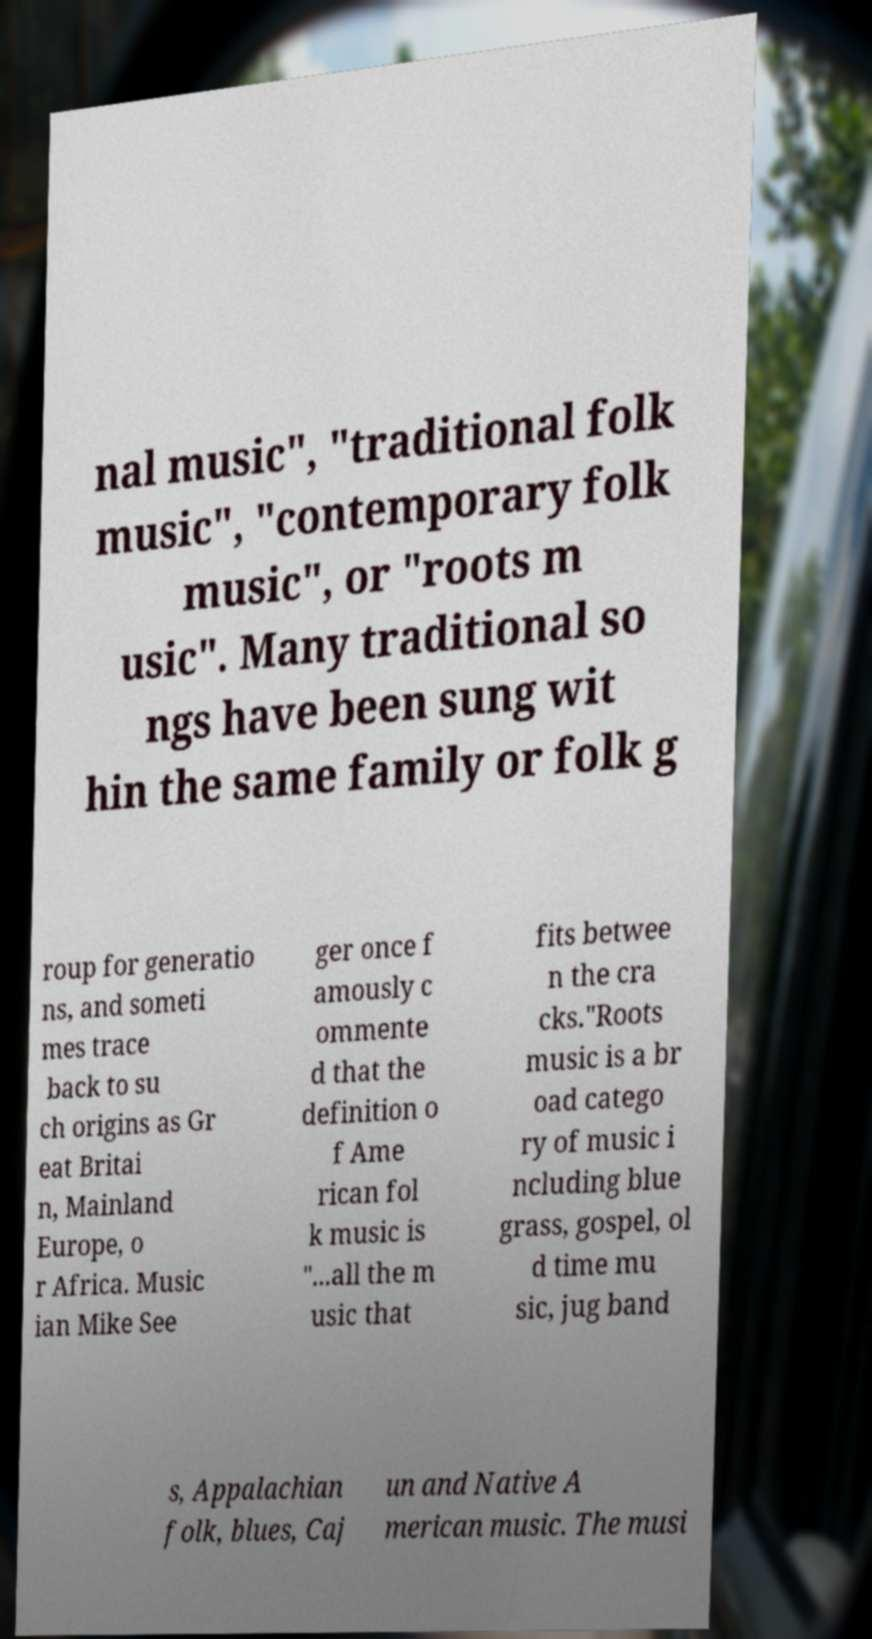Can you read and provide the text displayed in the image?This photo seems to have some interesting text. Can you extract and type it out for me? nal music", "traditional folk music", "contemporary folk music", or "roots m usic". Many traditional so ngs have been sung wit hin the same family or folk g roup for generatio ns, and someti mes trace back to su ch origins as Gr eat Britai n, Mainland Europe, o r Africa. Music ian Mike See ger once f amously c ommente d that the definition o f Ame rican fol k music is "...all the m usic that fits betwee n the cra cks."Roots music is a br oad catego ry of music i ncluding blue grass, gospel, ol d time mu sic, jug band s, Appalachian folk, blues, Caj un and Native A merican music. The musi 